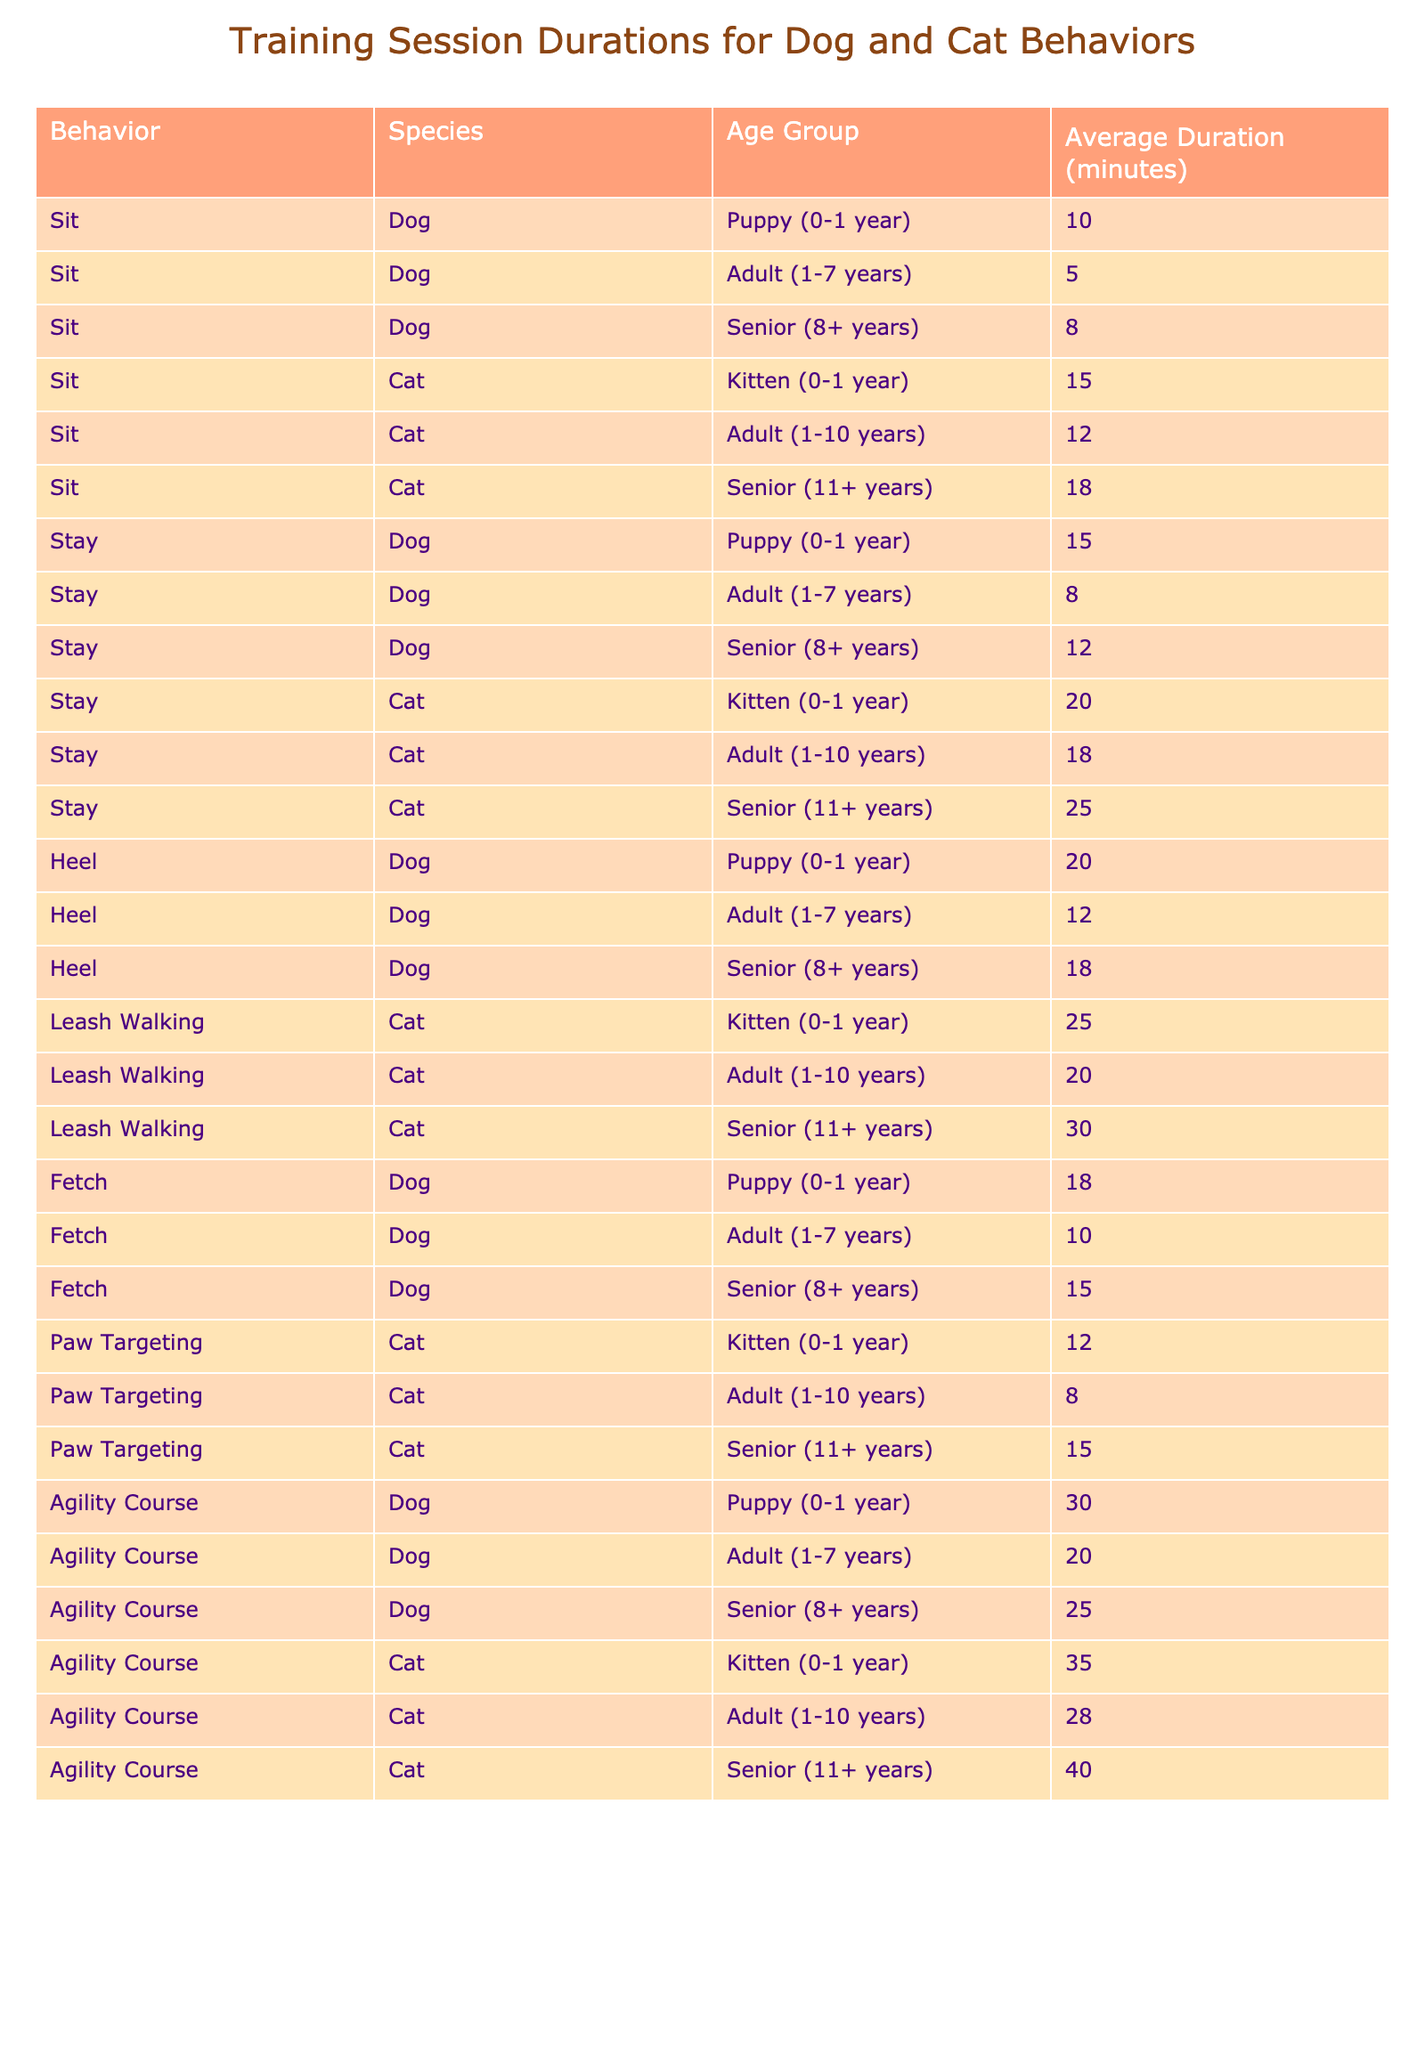What is the average duration for training "Sit" for dogs in the puppy age group? The average duration for training "Sit" for dogs in the puppy age group is listed in the table as 10 minutes.
Answer: 10 minutes How long does it take to train "Stay" for senior cats? In the table, the duration to train "Stay" for senior cats is provided as 25 minutes.
Answer: 25 minutes Which cat behavior takes the longest to train in the adult age group? The table shows that "Stay" for adult cats takes 18 minutes, while "Paw Targeting" takes 8 minutes. Therefore, "Stay" is the longest at 18 minutes.
Answer: Stay What is the difference in average training duration for "Fetch" between puppies and seniors in dogs? The average duration for "Fetch" in puppies is 18 minutes and in seniors is 15 minutes. The difference is 18 - 15 = 3 minutes.
Answer: 3 minutes Is the average duration for training "Agility Course" longer for senior cats than for senior dogs? According to the table, the average duration for "Agility Course" for senior cats is 40 minutes and for senior dogs is 25 minutes. Therefore, it is longer for senior cats.
Answer: Yes Which species, dog or cat, has a longer average duration for the "Heel" behavior in the adult age group? The average for dogs in adults is 12 minutes, and cats are not listed for this behavior, so the comparison can only be made for dogs. Thus, dogs have the longest duration at 12 minutes.
Answer: Dogs (12 minutes) What is the total average duration for "Leash Walking" across all age groups for cats? The average durations for "Leash Walking" for cats are 25 minutes (kitten), 20 minutes (adult), and 30 minutes (senior). The sum of these is 25 + 20 + 30 = 75 minutes. Then averaging over 3 age groups gives 75/3 = 25 minutes.
Answer: 25 minutes If we compare "Agility Course" training times for cats and dogs, how much longer is it for adult cats than for adult dogs? The duration for adult cats in "Agility Course" is 28 minutes and for adult dogs is 20 minutes. The difference is 28 - 20 = 8 minutes, so it’s longer by 8 minutes for adults cats.
Answer: 8 minutes For which behavior do senior dogs have the longest average training duration? In the table, "Agility Course" for senior dogs shows an average duration of 25 minutes, which is higher than "Sit" (8 minutes), "Stay" (12 minutes), or "Heel" (18 minutes). Therefore, "Agility Course" is the longest.
Answer: Agility Course What is the average training duration for all behaviors among puppies? To find this, we sum the durations for all puppy behaviors: Sit (10) + Stay (15) + Heel (20) + Fetch (18) + Agility Course (30) = 93 minutes. There are 5 behaviors, so the average is 93/5 = 18.6 minutes.
Answer: 18.6 minutes 